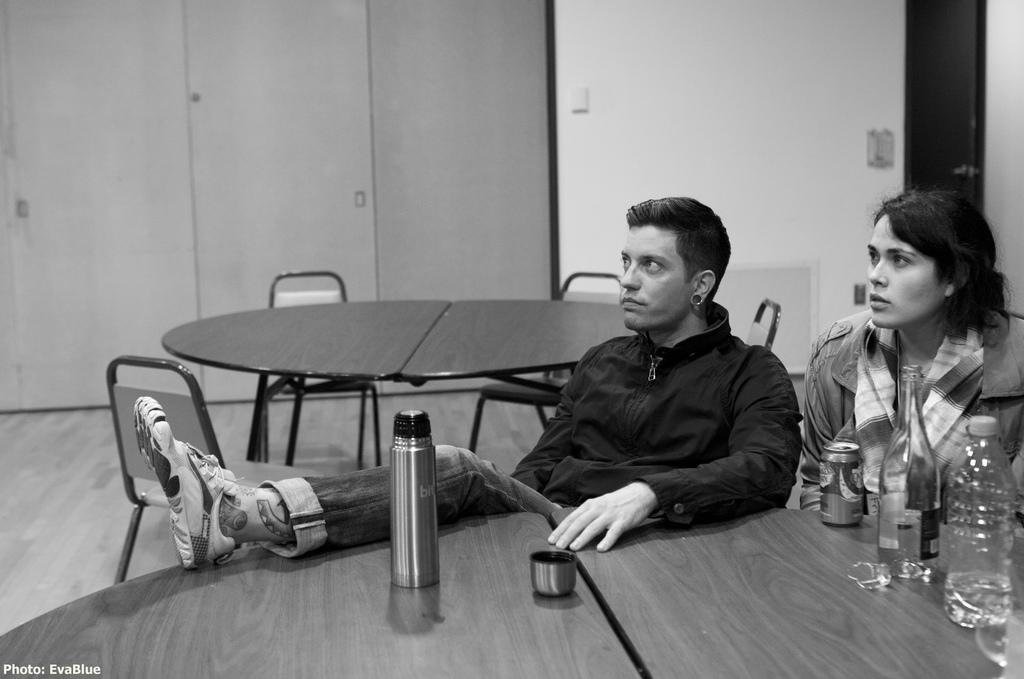How many people are in the image? There is a man and a woman in the image. What are the man and woman doing in the image? The man and woman are sitting on chairs. Where are the chairs located in relation to the table? The chairs are in front of the table. What can be seen on the table in the image? There are two glass bottles on the table, along with other unspecified items. What type of hose is being used to water the plants during the rainstorm in the image? There is no hose or rainstorm present in the image; it features a man and a woman sitting in front of a table with two glass bottles and other unspecified items. 